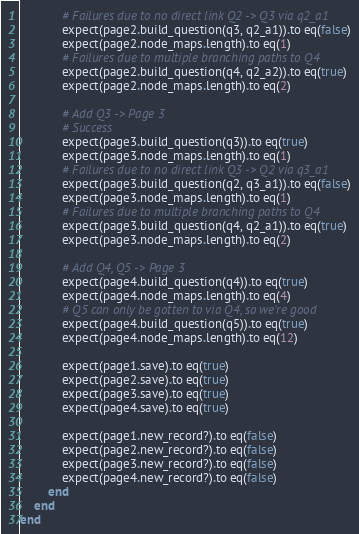Convert code to text. <code><loc_0><loc_0><loc_500><loc_500><_Ruby_>			# Failures due to no direct link Q2 -> Q3 via q2_a1
			expect(page2.build_question(q3, q2_a1)).to eq(false)
			expect(page2.node_maps.length).to eq(1)
			# Failures due to multiple branching paths to Q4
			expect(page2.build_question(q4, q2_a2)).to eq(true)
			expect(page2.node_maps.length).to eq(2)

			# Add Q3 -> Page 3
			# Success
			expect(page3.build_question(q3)).to eq(true)
			expect(page3.node_maps.length).to eq(1)
			# Failures due to no direct link Q3 -> Q2 via q3_a1
			expect(page3.build_question(q2, q3_a1)).to eq(false)
			expect(page3.node_maps.length).to eq(1)
			# Failures due to multiple branching paths to Q4
			expect(page3.build_question(q4, q2_a1)).to eq(true)
			expect(page3.node_maps.length).to eq(2)

			# Add Q4, Q5 -> Page 3
			expect(page4.build_question(q4)).to eq(true)
			expect(page4.node_maps.length).to eq(4)
			# Q5 can only be gotten to via Q4, so we're good
			expect(page4.build_question(q5)).to eq(true)
			expect(page4.node_maps.length).to eq(12)

			expect(page1.save).to eq(true)
			expect(page2.save).to eq(true)
			expect(page3.save).to eq(true)
			expect(page4.save).to eq(true)

			expect(page1.new_record?).to eq(false)
			expect(page2.new_record?).to eq(false)
			expect(page3.new_record?).to eq(false)
			expect(page4.new_record?).to eq(false)
		end
	end
end
</code> 